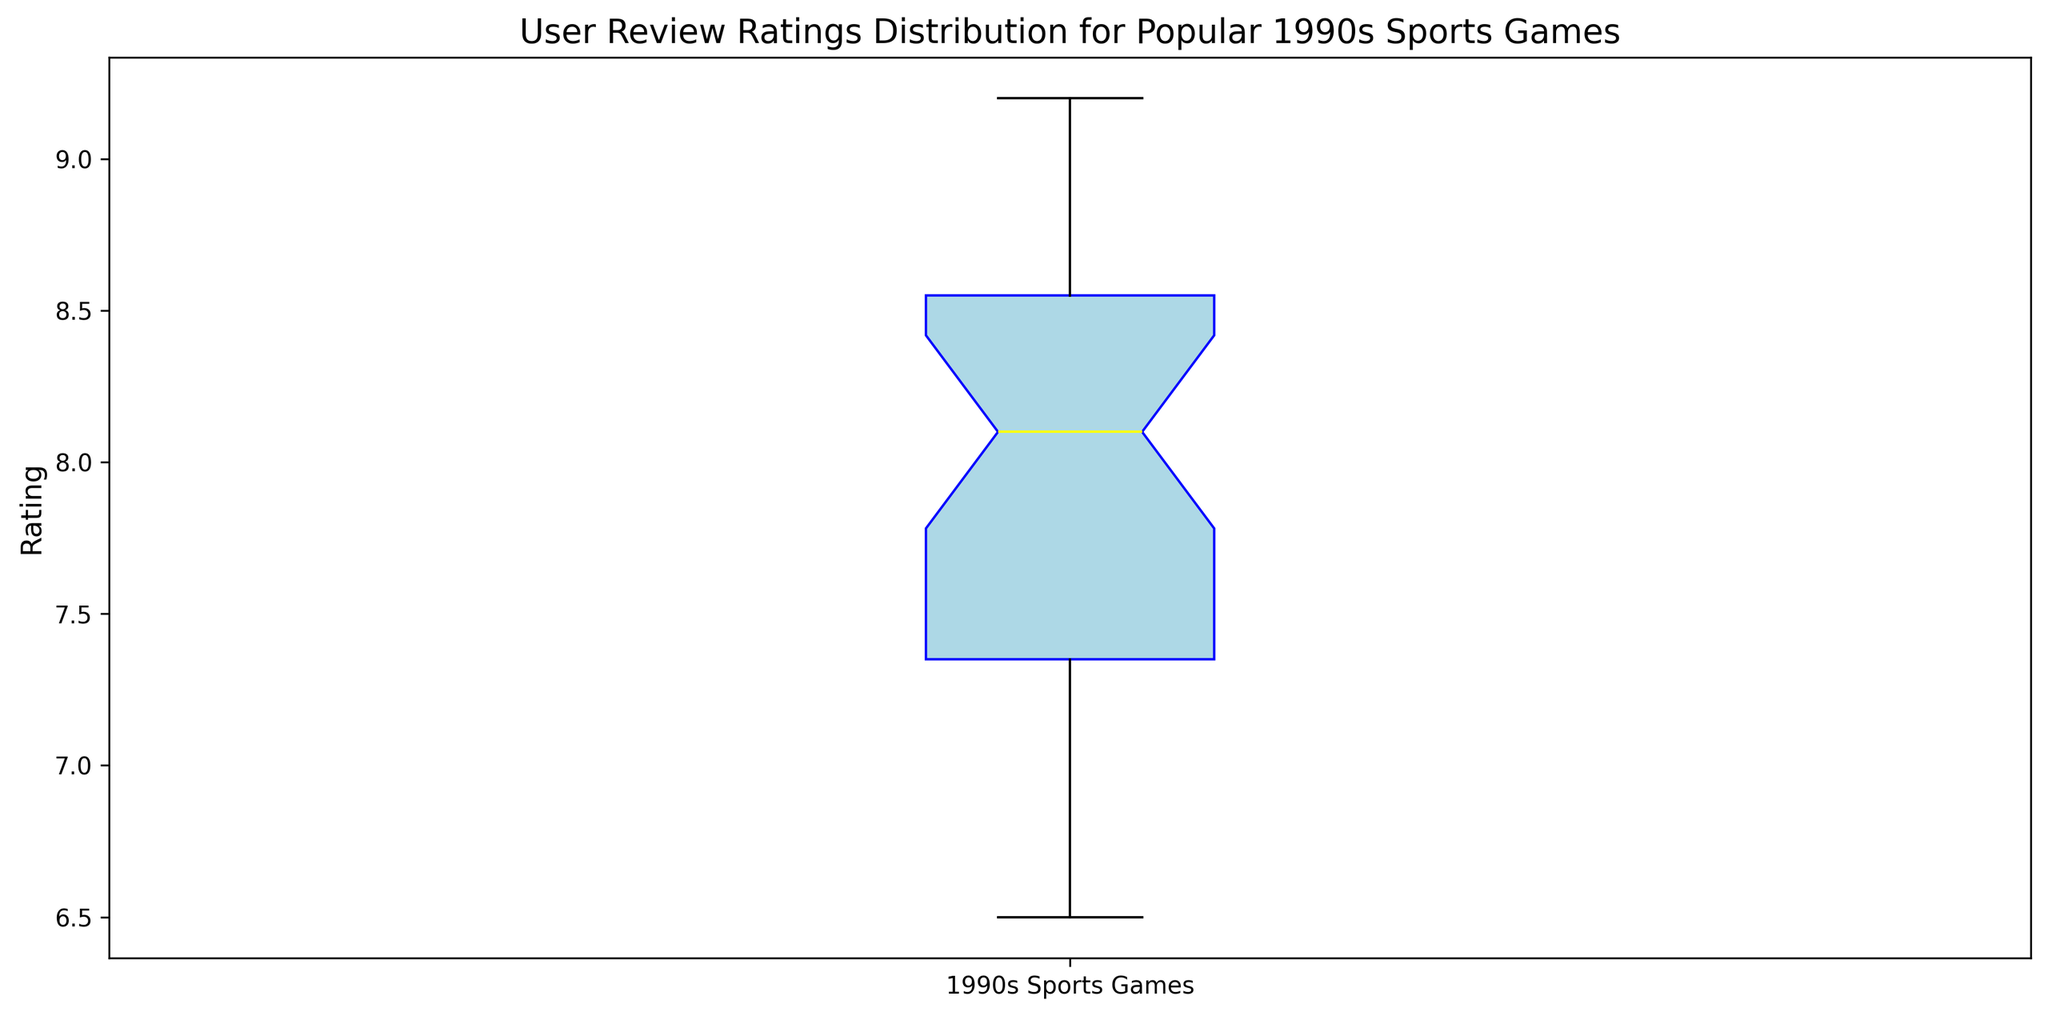What is the median user review rating for the games? The median of the box plot is indicated by the yellow line within the box. This line represents the median value of the dataset. By checking the yellow line on the plot, we can determine the median user review rating for the 1990s sports games.
Answer: 8.2 What is the interquartile range (IQR) of the user review ratings? The interquartile range (IQR) is the difference between the third quartile (Q3) and the first quartile (Q1). In the box plot, Q1 is the bottom of the box and Q3 is the top of the box. By visual inspection, estimate the values of Q1 and Q3, then subtract Q1 from Q3.
Answer: 8.75 - 7.4 = 1.35 What is the minimum user review rating indicated by the box plot? The minimum value is represented by the lower whisker of the box plot. This whisker extends from the bottom of the box to the smallest value in the dataset, excluding outliers. Look at the length of the lower whisker to determine the minimum rating.
Answer: 6.5 How many outliers are there and what are their rating values? Outliers in a box plot are represented by red markers outside the whiskers. By counting these red markers and checking their positions along the y-axis, we can determine the number of outliers and their corresponding rating values.
Answer: There are 3 outliers: 6.5, 6.7, 6.9 How does the median rating compare to the upper quartile (Q3) rating? The median rating is represented by the yellow line within the box, while the upper quartile (Q3) is the top of the box. By comparing the positions of these lines, we can see how the median rating compares to the Q3 rating.
Answer: The median (8.2) is less than the Q3 (8.75) What is the range of ratings encompassed by the lower whisker? The lower whisker represents the values from the minimum rating (excluding outliers) up to the first quartile (Q1). By identifying the values at the lower end of the plot, we can determine the range.
Answer: From 6.7 to 7.4 Describe the overall shape of the user review rating distribution. Observe the box plot to identify key characteristics such as the length of whiskers, the position of the median, and the spread of the IQR. These aspects reveal details about the symmetry, spread, and central tendency of the dataset.
Answer: The distribution is slightly skewed, with a concentration of ratings between 7.4 and 8.75, and a few lower outliers Is there more variation in the lower half or the upper half of the ratings? To determine variation, compare the lengths of the whiskers and boxes above and below the median. The variation is higher in the section where these lengths are greater.
Answer: More variation in the lower half What can be inferred if there are any rating values significantly higher than the upper whisker? If there are values significantly higher than the upper whisker, those ratings are considered outliers and indicate games that received exceptionally high user reviews.
Answer: Indicates exceptionally high ratings Between which values does the middle 50% of the user ratings lie? The middle 50% of user ratings lie between Q1 and Q3. These quartiles are represented by the lower and upper edges of the box. By identifying these values, we can determine the range of the middle 50%.
Answer: Between 7.4 and 8.75 